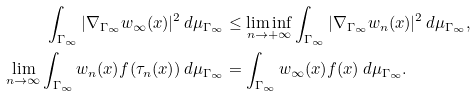<formula> <loc_0><loc_0><loc_500><loc_500>\int _ { \Gamma _ { \infty } } | \nabla _ { \Gamma _ { \infty } } w _ { \infty } ( x ) | ^ { 2 } \, d \mu _ { \Gamma _ { \infty } } & \leq \liminf _ { n \to + \infty } \int _ { \Gamma _ { \infty } } | \nabla _ { \Gamma _ { \infty } } w _ { n } ( x ) | ^ { 2 } \, d \mu _ { \Gamma _ { \infty } } , \\ \lim _ { n \to \infty } \int _ { \Gamma _ { \infty } } w _ { n } ( x ) f ( \tau _ { n } ( x ) ) \, d \mu _ { \Gamma _ { \infty } } & = \int _ { \Gamma _ { \infty } } w _ { \infty } ( x ) f ( x ) \, d \mu _ { \Gamma _ { \infty } } .</formula> 